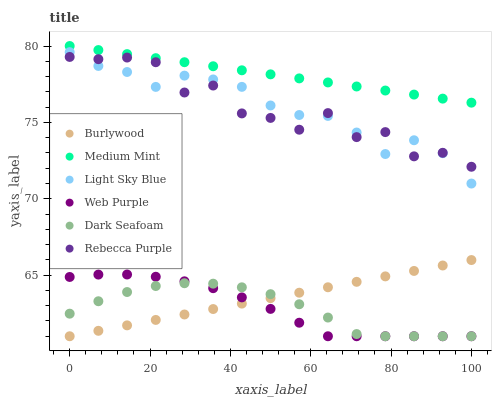Does Dark Seafoam have the minimum area under the curve?
Answer yes or no. Yes. Does Medium Mint have the maximum area under the curve?
Answer yes or no. Yes. Does Burlywood have the minimum area under the curve?
Answer yes or no. No. Does Burlywood have the maximum area under the curve?
Answer yes or no. No. Is Burlywood the smoothest?
Answer yes or no. Yes. Is Rebecca Purple the roughest?
Answer yes or no. Yes. Is Dark Seafoam the smoothest?
Answer yes or no. No. Is Dark Seafoam the roughest?
Answer yes or no. No. Does Burlywood have the lowest value?
Answer yes or no. Yes. Does Light Sky Blue have the lowest value?
Answer yes or no. No. Does Medium Mint have the highest value?
Answer yes or no. Yes. Does Burlywood have the highest value?
Answer yes or no. No. Is Burlywood less than Medium Mint?
Answer yes or no. Yes. Is Rebecca Purple greater than Dark Seafoam?
Answer yes or no. Yes. Does Rebecca Purple intersect Light Sky Blue?
Answer yes or no. Yes. Is Rebecca Purple less than Light Sky Blue?
Answer yes or no. No. Is Rebecca Purple greater than Light Sky Blue?
Answer yes or no. No. Does Burlywood intersect Medium Mint?
Answer yes or no. No. 